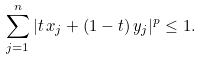<formula> <loc_0><loc_0><loc_500><loc_500>\sum _ { j = 1 } ^ { n } | t \, x _ { j } + ( 1 - t ) \, y _ { j } | ^ { p } \leq 1 .</formula> 